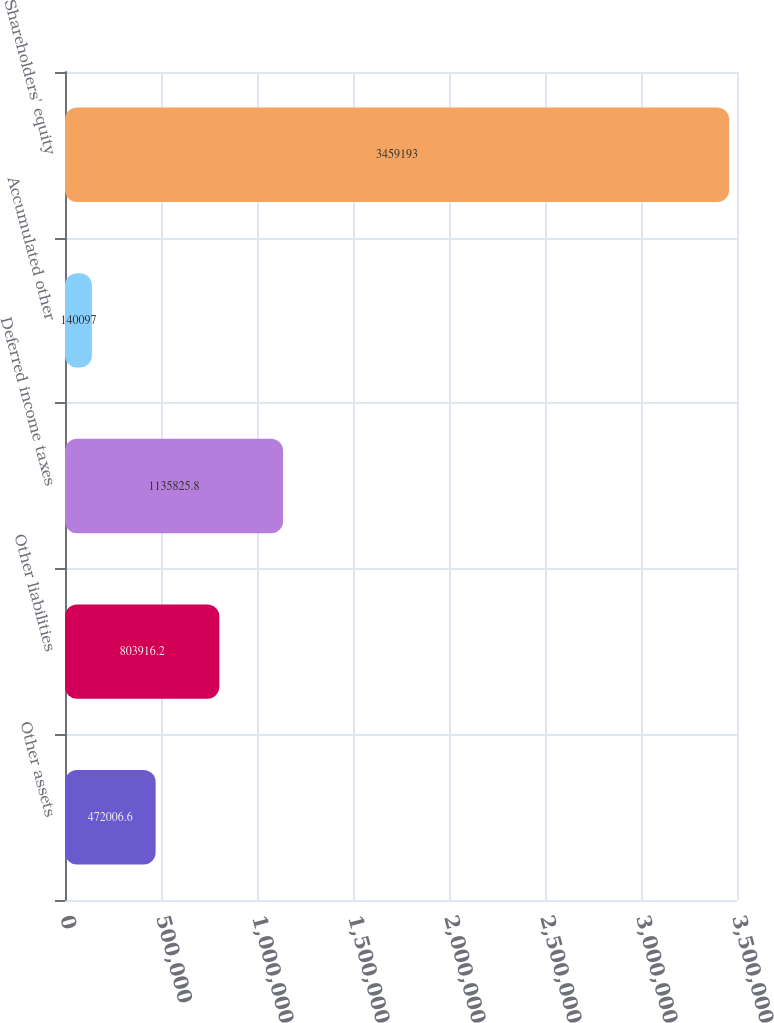Convert chart. <chart><loc_0><loc_0><loc_500><loc_500><bar_chart><fcel>Other assets<fcel>Other liabilities<fcel>Deferred income taxes<fcel>Accumulated other<fcel>Shareholders' equity<nl><fcel>472007<fcel>803916<fcel>1.13583e+06<fcel>140097<fcel>3.45919e+06<nl></chart> 